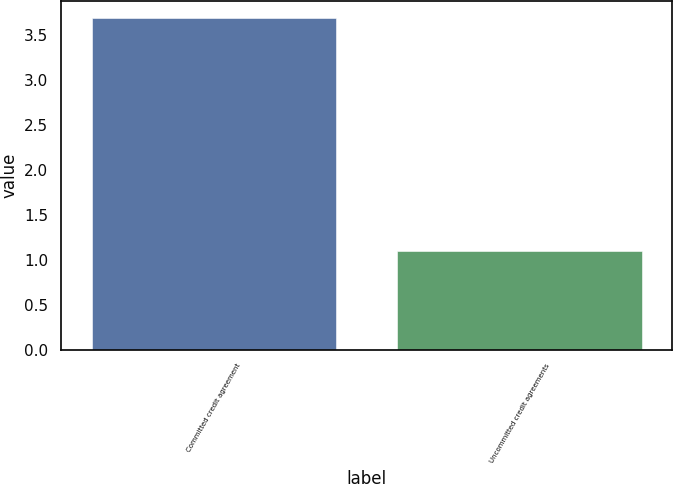Convert chart. <chart><loc_0><loc_0><loc_500><loc_500><bar_chart><fcel>Committed credit agreement<fcel>Uncommitted credit agreements<nl><fcel>3.7<fcel>1.1<nl></chart> 